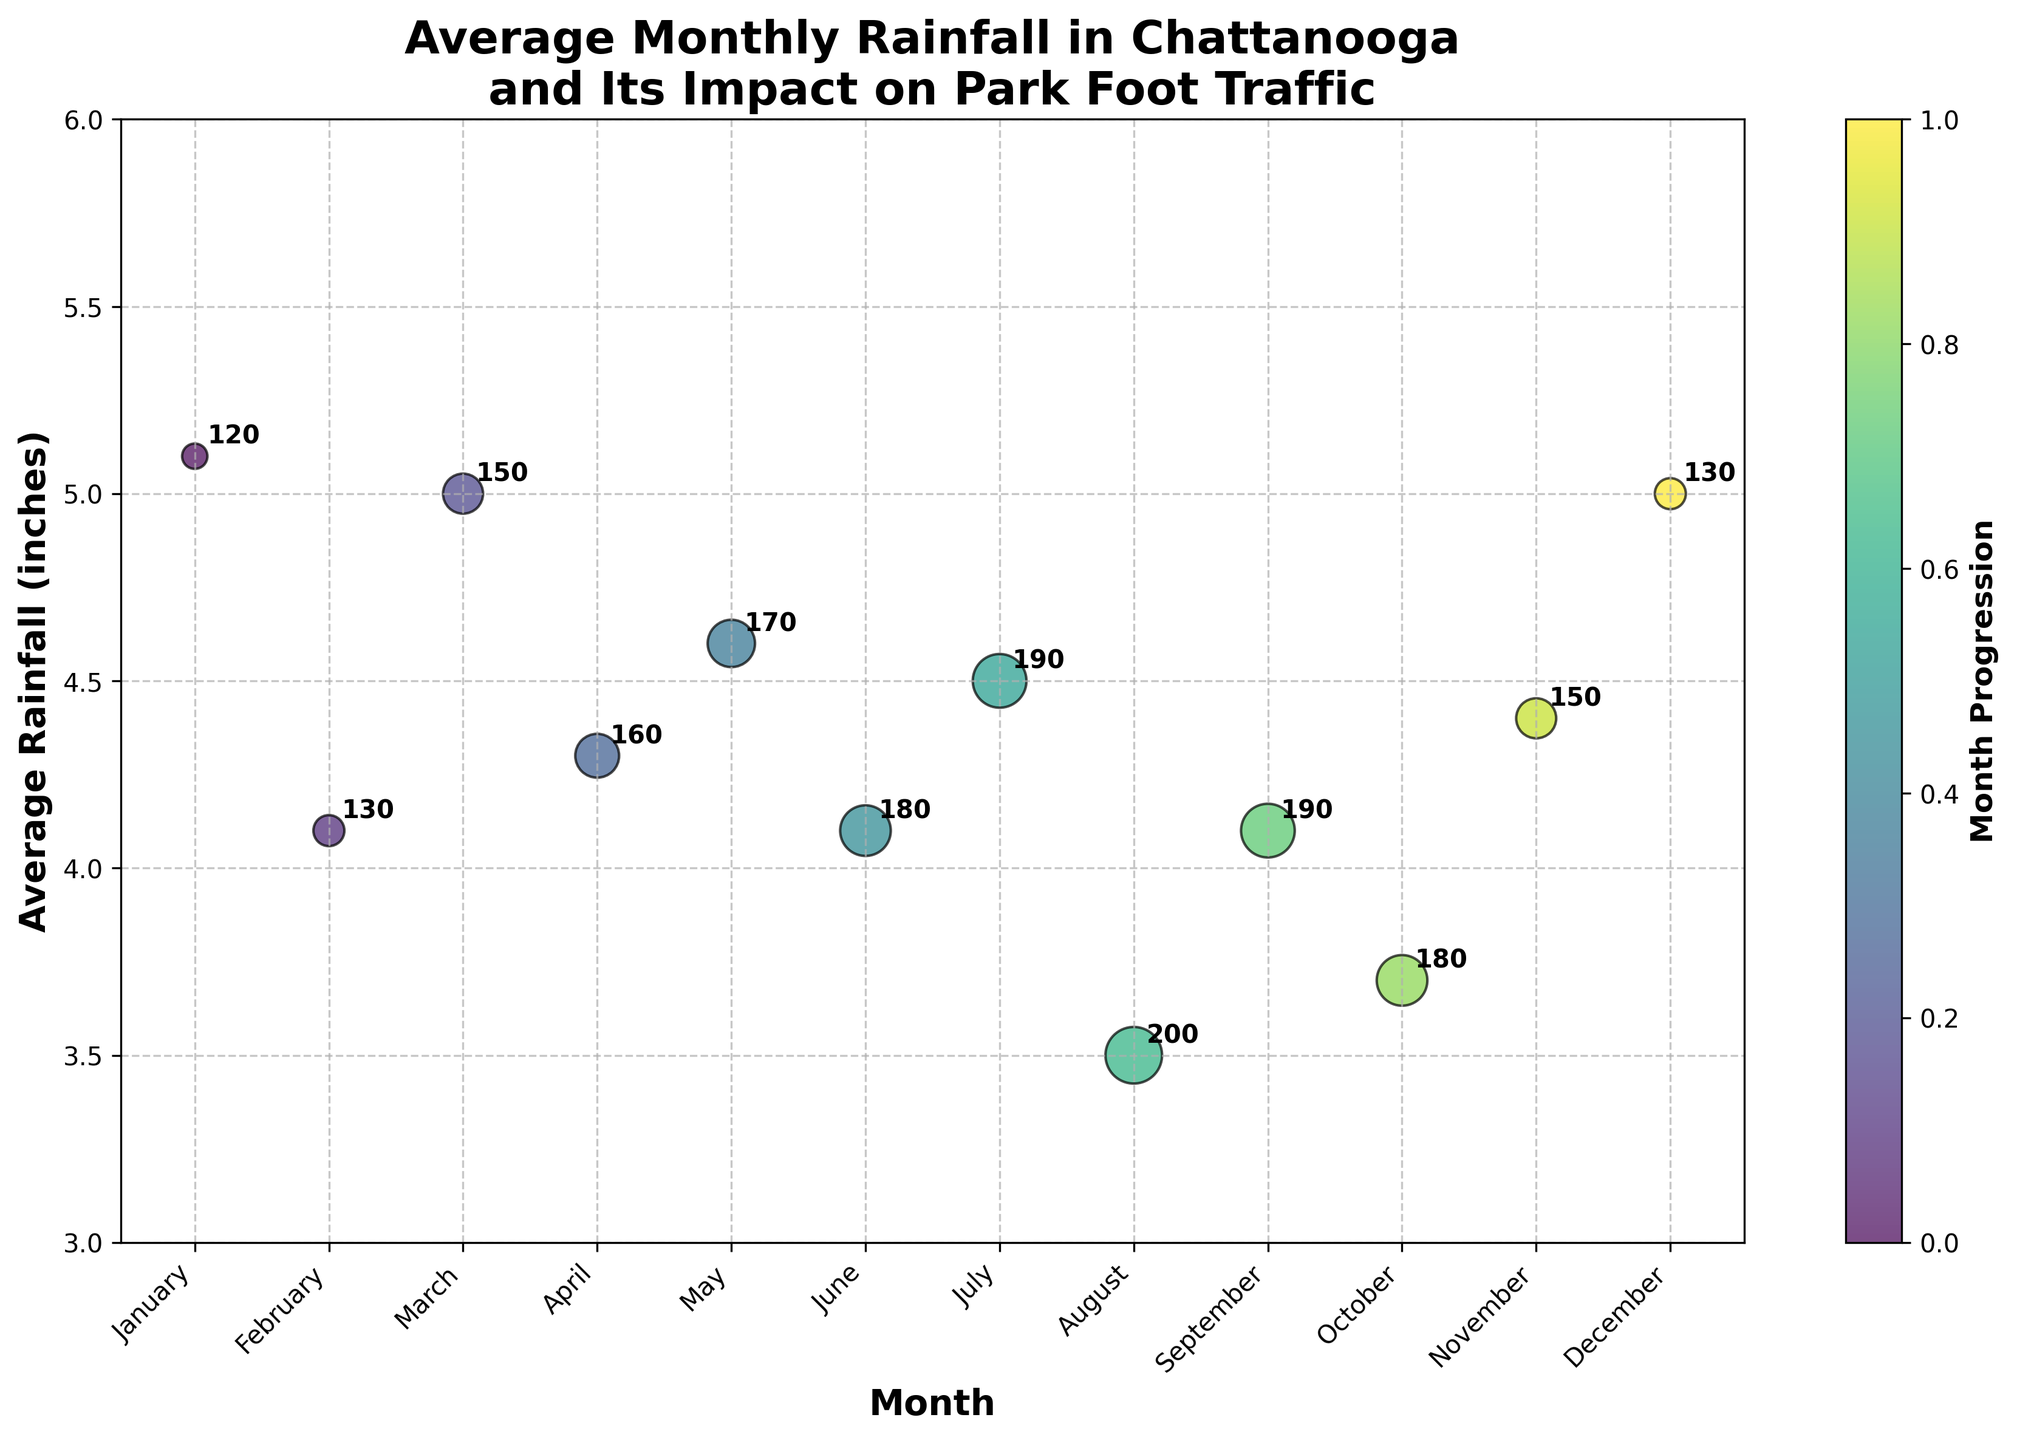What is the highest amount of rainfall recorded in any month? The highest rainfall value can be observed by looking at the y-axis and finding the highest point corresponding to any bubble. From the data points, January and December both have the highest rainfall at 5.1 inches.
Answer: 5.1 inches Which month has the highest park foot traffic? To find the month with the highest foot traffic, look for the largest bubble size on the chart, as the size represents foot traffic. The largest bubble corresponds to August.
Answer: August Is the park busier in months with less rainfall or more rainfall? Compare the sizes of bubbles (representing foot traffic) in months with less rainfall and more rainfall. Generally, bubbles corresponding to months with less rainfall (e.g., August has the least rainfall) are larger, indicating higher foot traffic when there's less rain.
Answer: Less rainfall What is the range of rainfall observed in the data set? Subtract the smallest rainfall value from the largest. The smallest rainfall is 3.5 inches (August), and the largest is 5.1 inches (January and December). So, the range is 5.1 - 3.5 = 1.6 inches.
Answer: 1.6 inches How does July's foot traffic compare to February's foot traffic? Identify the bubble for July and the bubble for February, and compare their sizes. July's foot traffic (190 people per day) is significantly higher than February's foot traffic (130 people per day).
Answer: July > February Does the month with the least rainfall always have the highest foot traffic? Look for the month with the least rainfall (August, 3.5 inches) and check its foot traffic. August indeed has the highest foot traffic with 200 people per day.
Answer: Yes Which months have the same amount of rainfall but different park foot traffic? Examine the data points on the y-axis with the same rainfall value. February, June, and September all have 4.1 inches of rainfall but different foot traffic values of 130, 180, and 190 people per day, respectively.
Answer: February, June, September What is the general trend between rainfall and park foot traffic? Observe the plot to see if there is a pattern. Generally, months with less rainfall tend to have larger bubbles, indicating higher foot traffic when rainfall is lower.
Answer: Less rainfall, more foot traffic 